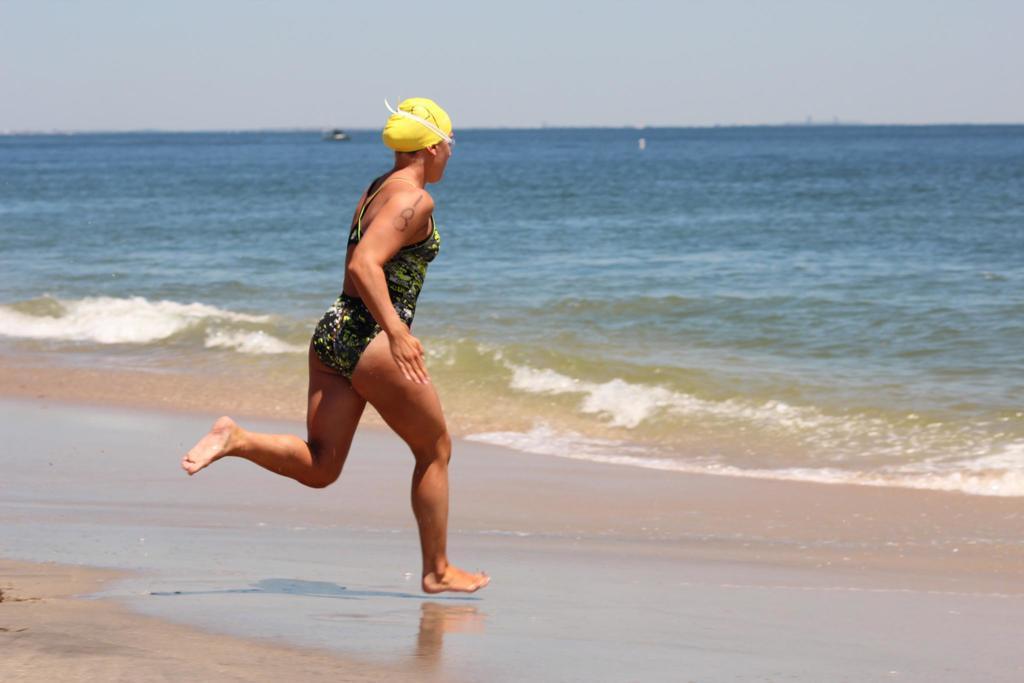Can you describe this image briefly? In the foreground of the picture there is a woman running on the beach. In the center of the picture there is a water body. In the background it is sky. 